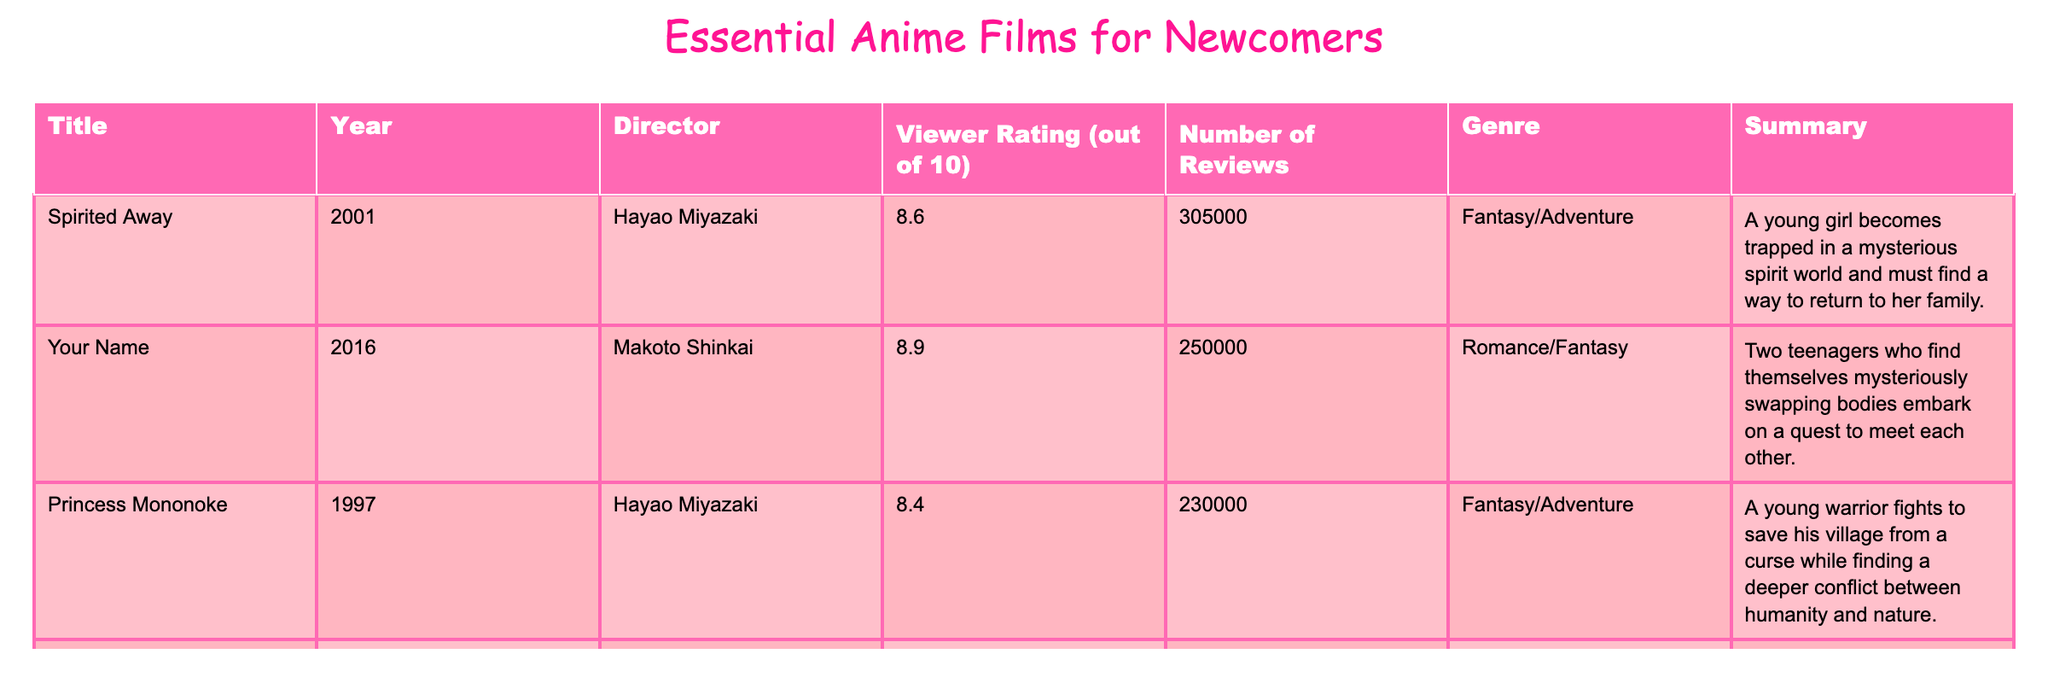What is the viewer rating of "Your Name"? The table lists the viewer rating for "Your Name" under the "Viewer Rating" column. Looking at the data, it shows that "Your Name" has a rating of 8.9.
Answer: 8.9 How many reviews does "Spirited Away" have? The number of reviews for "Spirited Away" is found in the "Number of Reviews" column. According to the data, "Spirited Away" has 305000 reviews.
Answer: 305000 Which film has the highest viewer rating? To find the film with the highest viewer rating, we need to compare the ratings of each film listed. The ratings are 8.6 for "Spirited Away", 8.9 for "Your Name", 8.4 for "Princess Mononoke", and 8.0 for "Ghost in the Shell". The highest rating is 8.9 for "Your Name".
Answer: Your Name What is the average viewer rating of all the films? The viewer ratings are 8.6, 8.9, 8.4, and 8.0. To calculate the average, we sum these ratings: 8.6 + 8.9 + 8.4 + 8.0 = 34.9. Then, we divide by the number of films (4): 34.9 / 4 = 8.725.
Answer: 8.725 Is "Ghost in the Shell" a fantasy film? "Ghost in the Shell" is categorized under the "Genre" column as Sci-Fi/Action, which indicates it is not a fantasy film. Therefore, the statement is false.
Answer: No Which genre has the most films listed in this table? We analyze the genres associated with each film. The genres are Fantasy/Adventure (2 films: "Spirited Away", "Princess Mononoke"), Romance/Fantasy (1 film), and Sci-Fi/Action (1 film). Since Fantasy/Adventure appears twice, it is the genre with the most films.
Answer: Fantasy/Adventure What is the total number of reviews for films directed by Hayao Miyazaki? The films directed by Hayao Miyazaki are "Spirited Away" and "Princess Mononoke". Their review counts are 305000 and 230000, respectively. Adding these gives us: 305000 + 230000 = 535000.
Answer: 535000 Does "Your Name" have more reviews than "Ghost in the Shell"? "Your Name" has 250000 reviews, while "Ghost in the Shell" has 70000 reviews. Since 250000 is greater than 70000, the statement is true.
Answer: Yes What year was "Princess Mononoke" released? The release year of "Princess Mononoke" is found in the "Year" column. According to the data, it was released in 1997.
Answer: 1997 